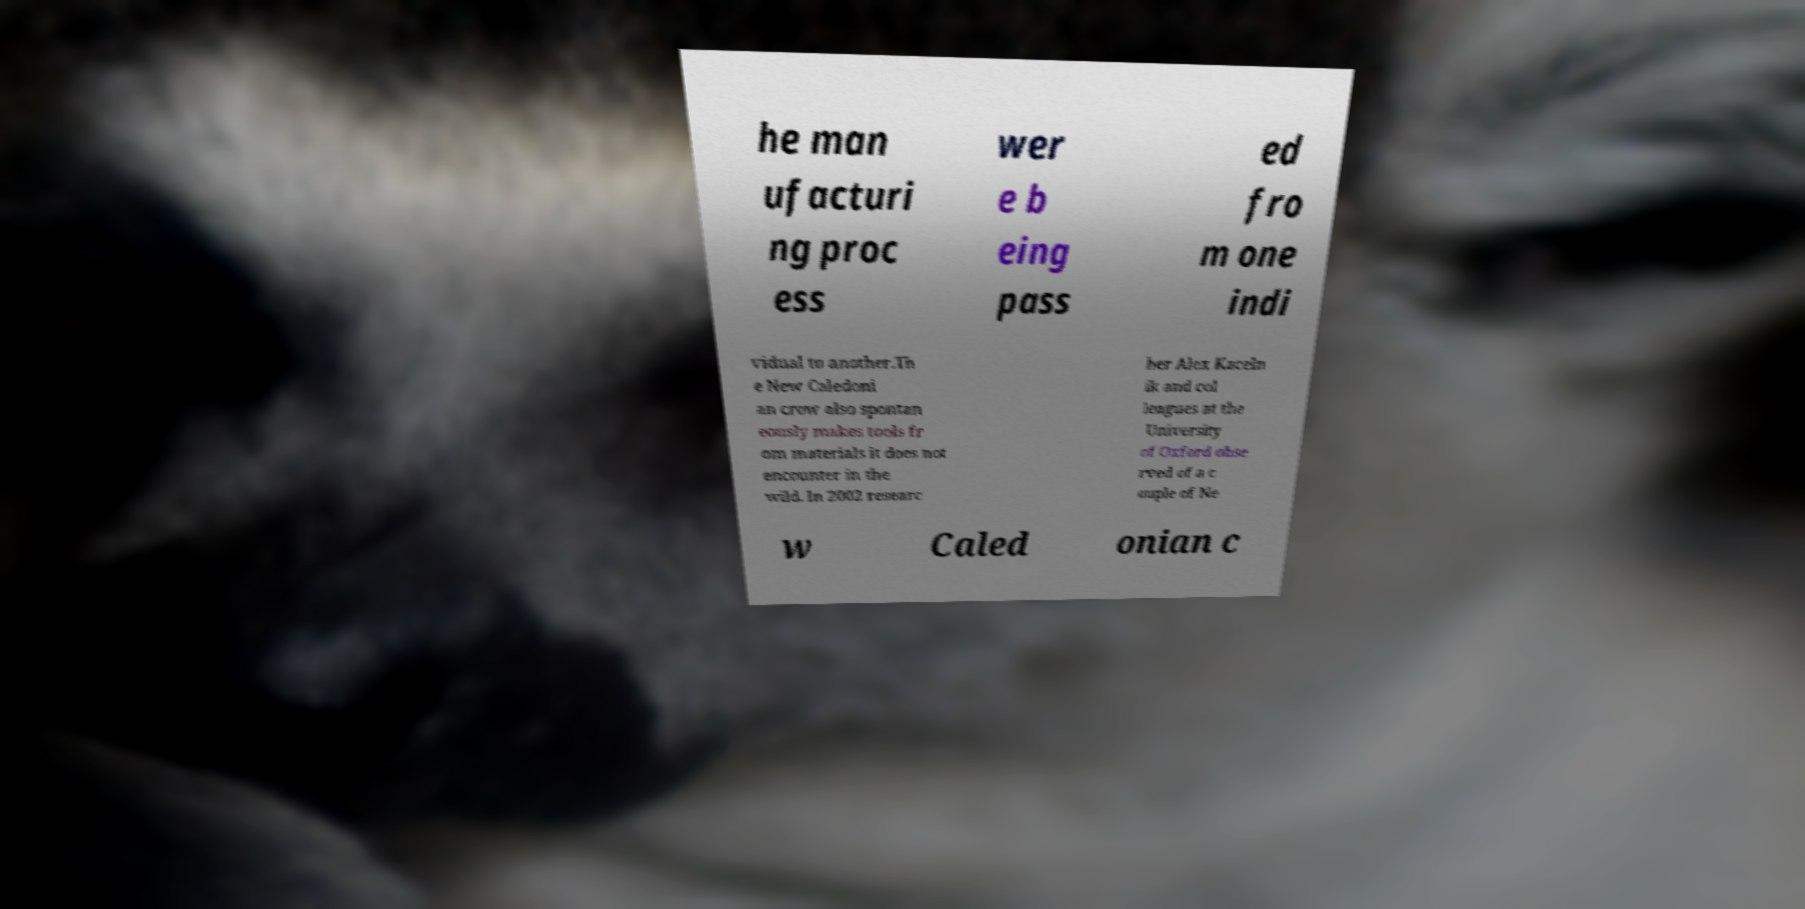There's text embedded in this image that I need extracted. Can you transcribe it verbatim? he man ufacturi ng proc ess wer e b eing pass ed fro m one indi vidual to another.Th e New Caledoni an crow also spontan eously makes tools fr om materials it does not encounter in the wild. In 2002 researc her Alex Kaceln ik and col leagues at the University of Oxford obse rved of a c ouple of Ne w Caled onian c 